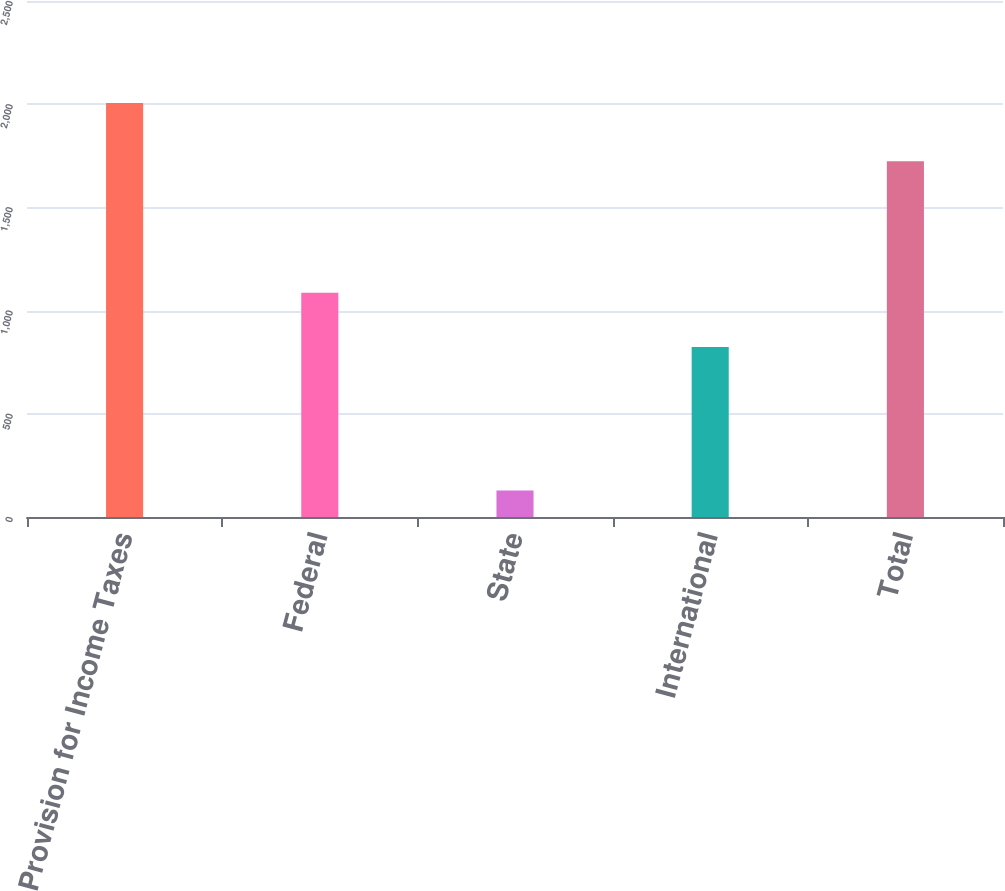Convert chart to OTSL. <chart><loc_0><loc_0><loc_500><loc_500><bar_chart><fcel>Provision for Income Taxes<fcel>Federal<fcel>State<fcel>International<fcel>Total<nl><fcel>2006<fcel>1087<fcel>128<fcel>824<fcel>1723<nl></chart> 